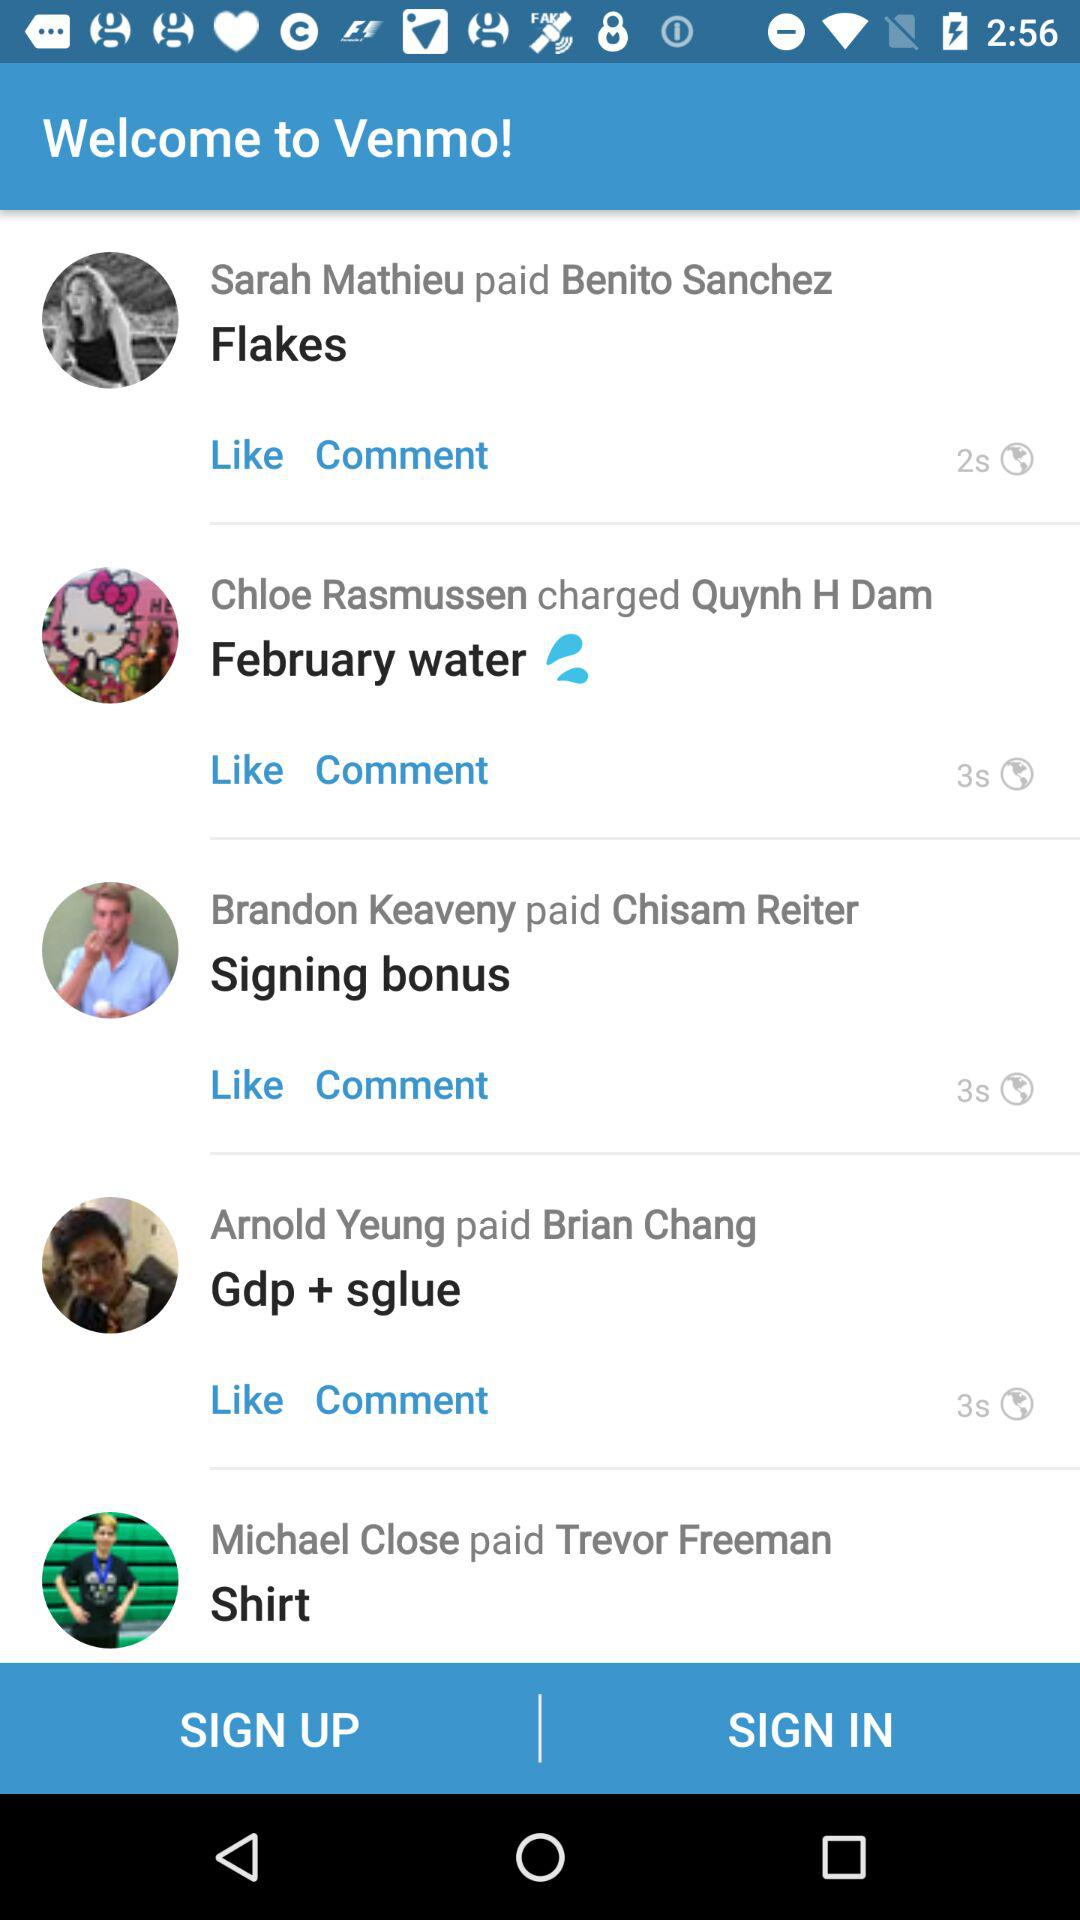Who paid Trevor Freeman? Trevor Freeman was paid by Michael Close. 